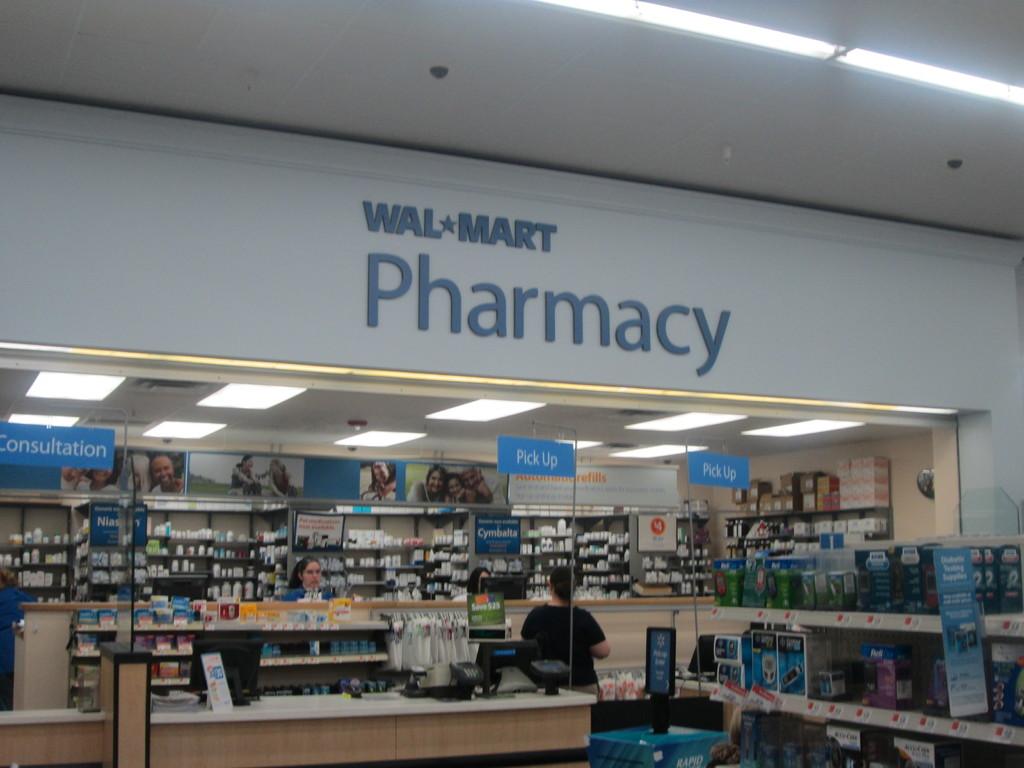What section of the store is this?
Ensure brevity in your answer.  Pharmacy. What store is this?
Your answer should be compact. Walmart. 